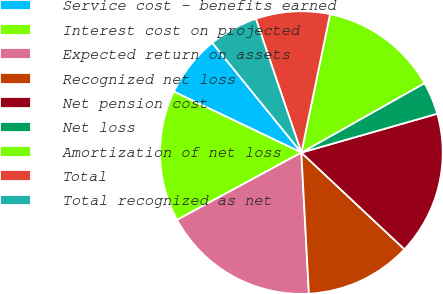<chart> <loc_0><loc_0><loc_500><loc_500><pie_chart><fcel>Service cost - benefits earned<fcel>Interest cost on projected<fcel>Expected return on assets<fcel>Recognized net loss<fcel>Net pension cost<fcel>Net loss<fcel>Amortization of net loss<fcel>Total<fcel>Total recognized as net<nl><fcel>7.05%<fcel>15.0%<fcel>17.95%<fcel>12.16%<fcel>16.42%<fcel>3.74%<fcel>13.58%<fcel>8.47%<fcel>5.63%<nl></chart> 